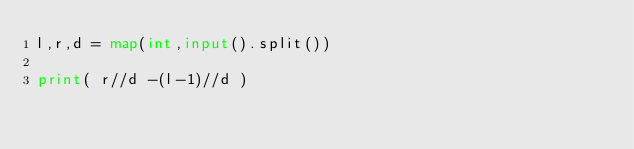<code> <loc_0><loc_0><loc_500><loc_500><_Python_>l,r,d = map(int,input().split())
     
print( r//d -(l-1)//d )</code> 